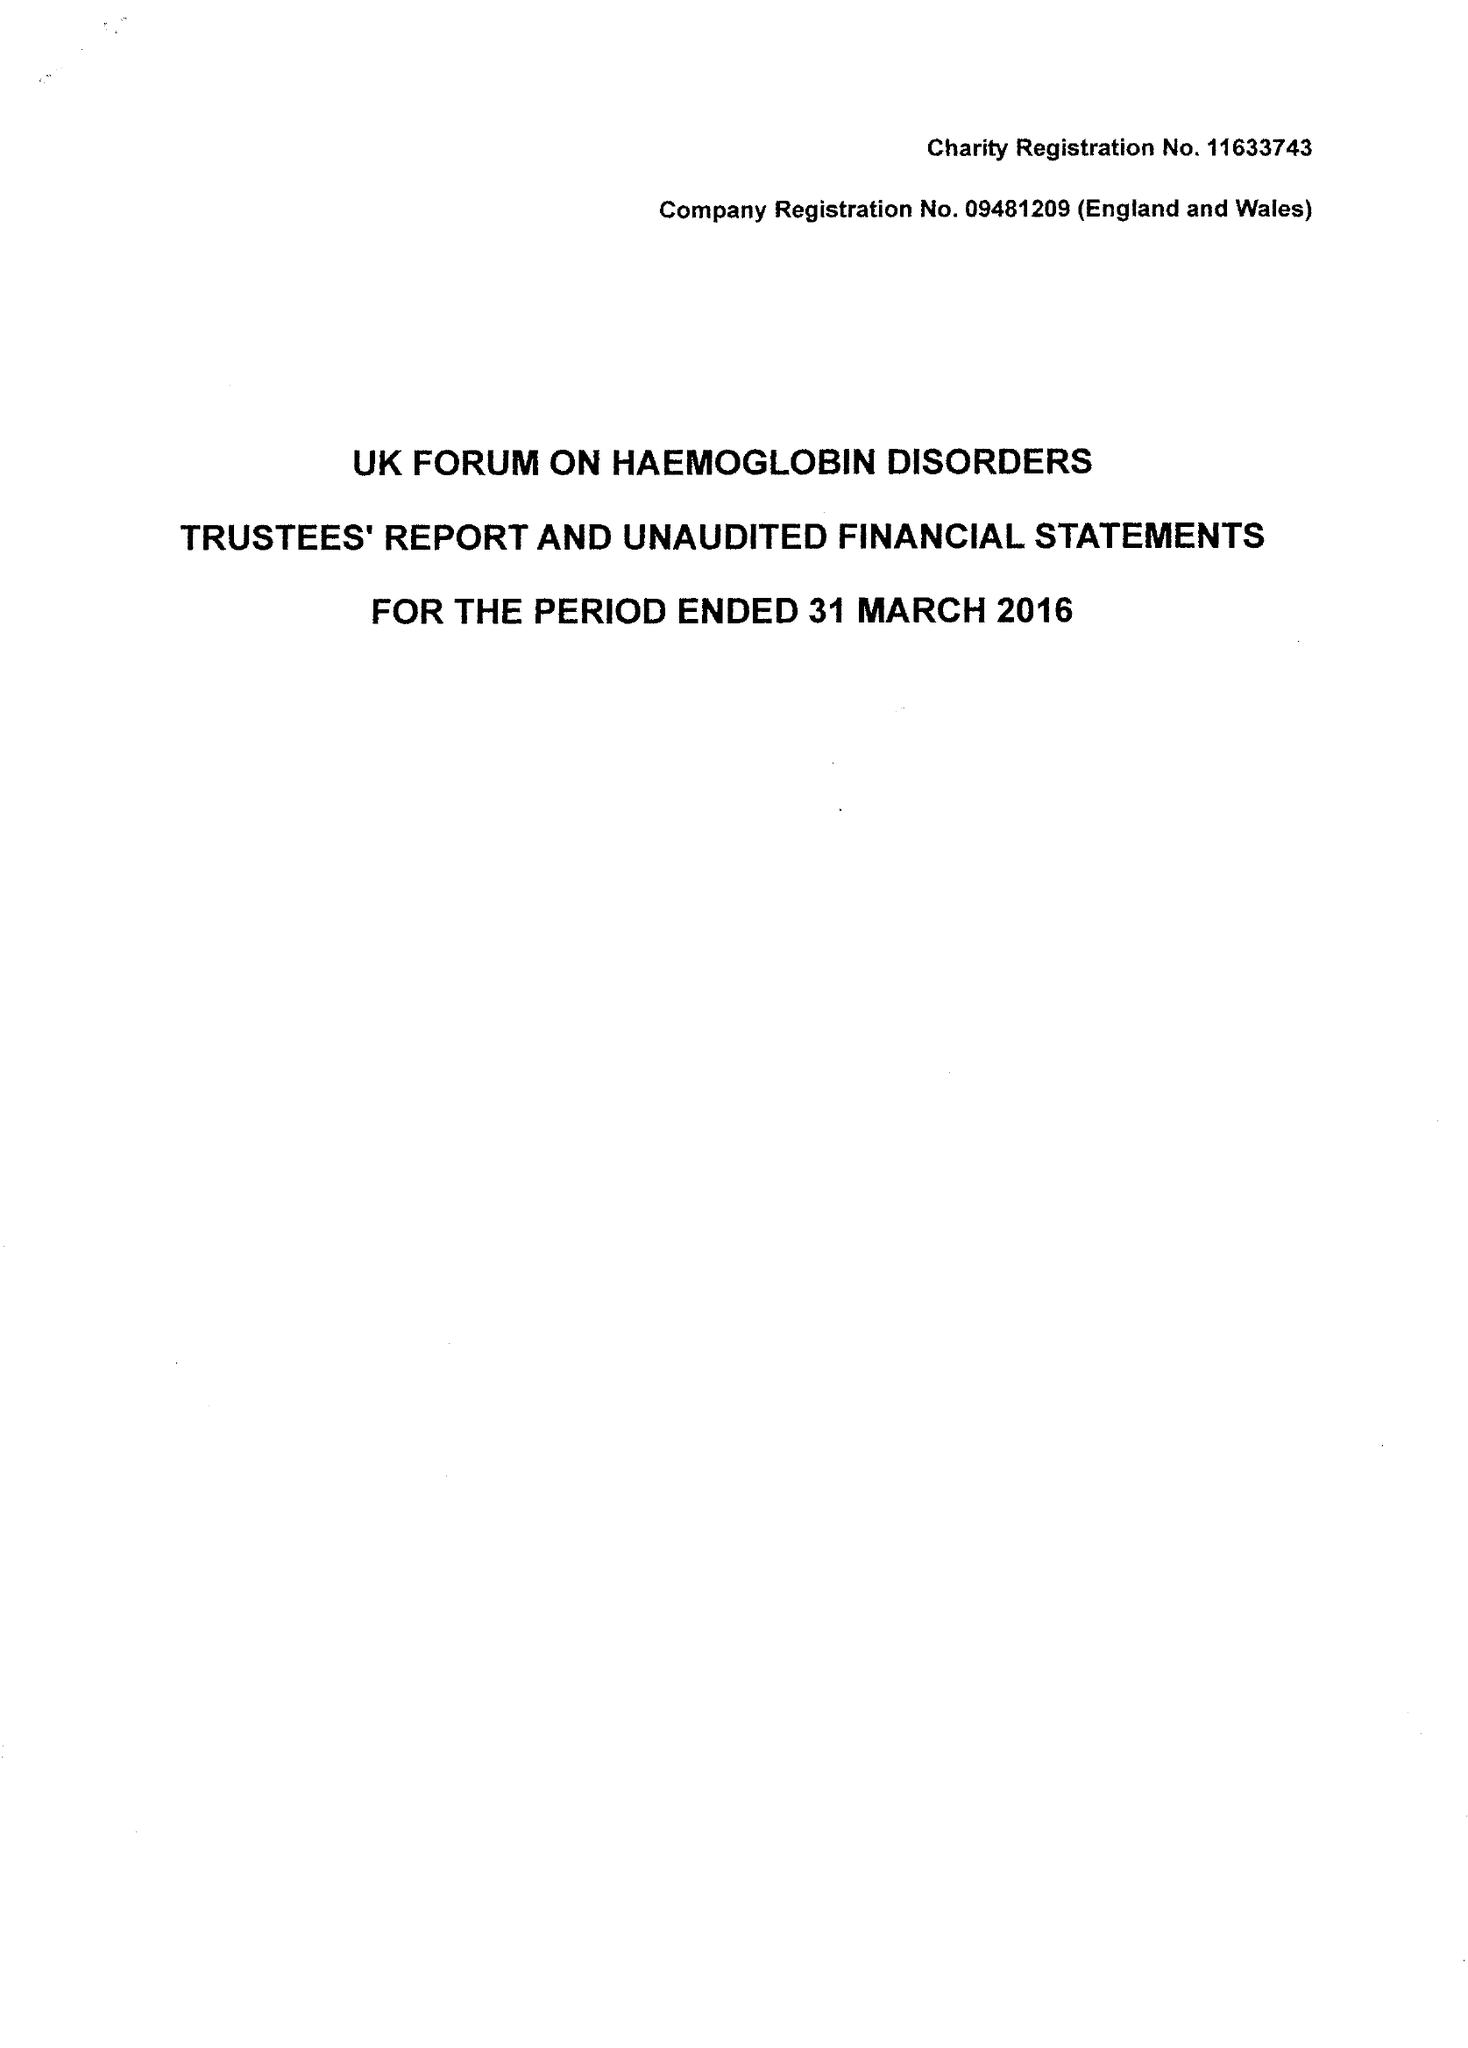What is the value for the charity_name?
Answer the question using a single word or phrase. Uk Forum On Haemoglobin Disorders 